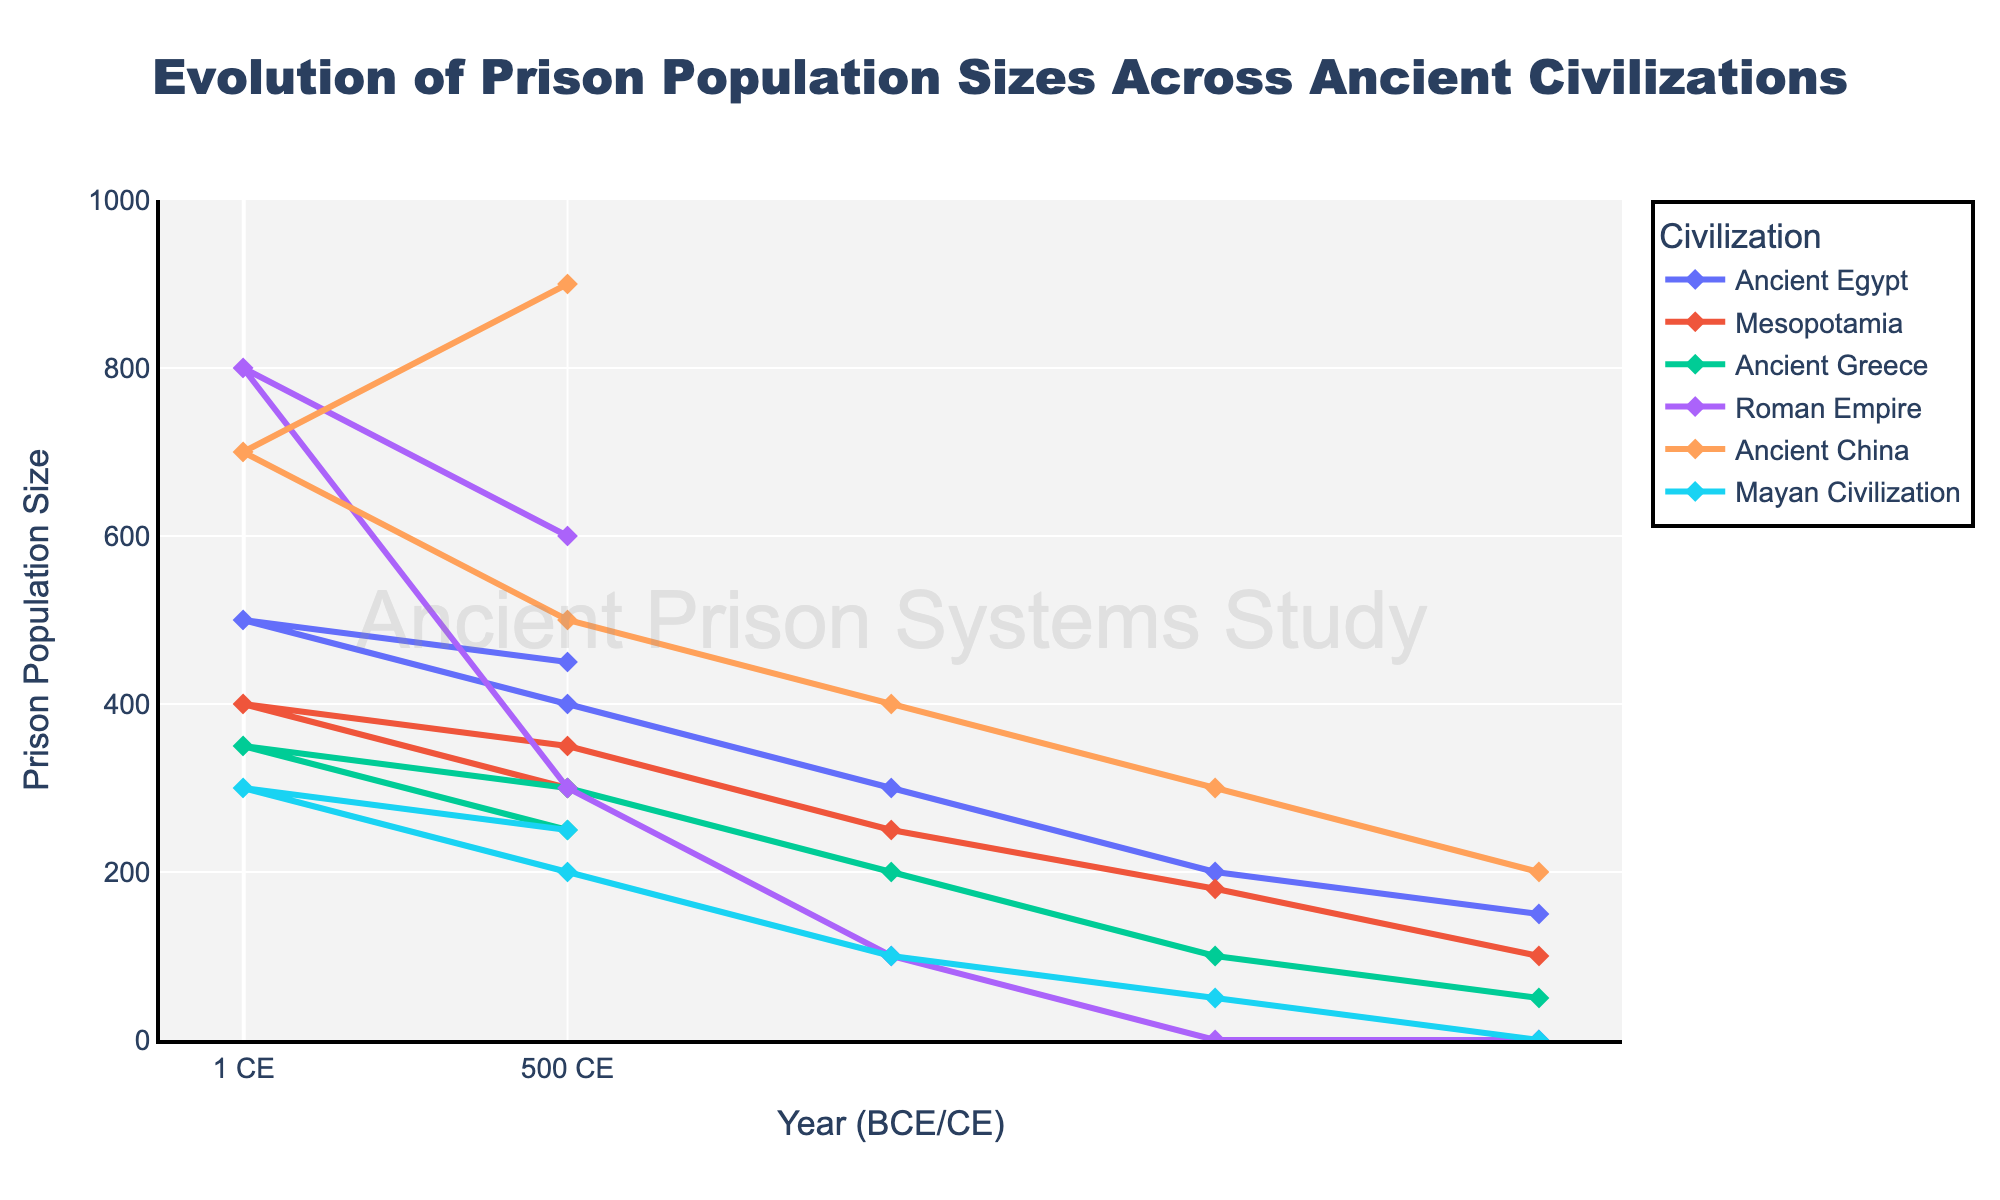Which civilization had the highest prison population in 1 CE? By looking at the data points for the year 1 CE, the Roman Empire had the highest prison population of 800.
Answer: Roman Empire How did the prison population of Ancient China change from 1000 BCE to 500 CE? For Ancient China, the prison populations at 1000 BCE and 500 CE are 400 and 900, respectively. The change is 900 - 400 = 500.
Answer: Increased by 500 Which civilization experienced a decrease in prison population size from 1 CE to 500 CE? By examining the visual trends from 1 CE to 500 CE, Mesopotamia is the only civilization where the prison population decreases from 400 to 300.
Answer: Mesopotamia Between 2000 BCE and 1 CE, which two civilizations had the most consistent growth in prison population? Both Ancient Egypt and Ancient China show steady, almost linear increases in their prison populations in each period from 2000 BCE to 1 CE.
Answer: Ancient Egypt and Ancient China What is the average prison population of the Mayan Civilization from 500 BCE to 500 CE? The populations for the Mayan Civilization are 100, 200, 300, and 250 in these years. Thus, the average is (100 + 200 + 300 + 250) / 4 = 212.5.
Answer: 212.5 Which civilization had zero prison population before 1000 BCE and what is its significance? The civilizations with zero population before 1000 BCE are the Roman Empire and the Mayan Civilization, indicating they likely did not have formal prison systems or records before these dates.
Answer: Roman Empire and Mayan Civilization What is the total change in prison population size for Ancient Greece between 2000 BCE and 500 CE? The prison populations for Ancient Greece are 50 at 2000 BCE and 250 at 500 CE. Thus, the total change is 250 - 50 = 200.
Answer: 200 Which civilization had a prison population that peaked in 500 CE? The Roman Empire had a prison population that peaked at 800 in 1 CE and then reduced to 600 by 500 CE, but Ancient China continued to increase to 900 by 500 CE.
Answer: Ancient China Compare the growth in prison populations of Mesopotamia and Ancient Egypt between 1500 BCE and 1 CE. Mesopotamia grows from 180 to 400 (220 increase), while Ancient Egypt grows from 200 to 500 (300 increase) within the same timeframe.
Answer: Ancient Egypt had a greater increase 